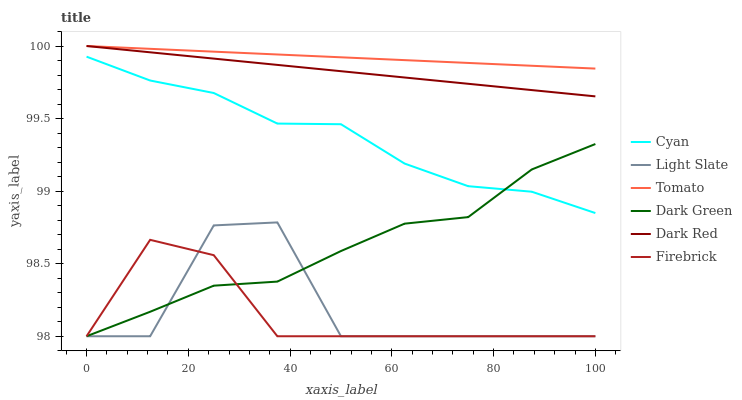Does Firebrick have the minimum area under the curve?
Answer yes or no. Yes. Does Tomato have the maximum area under the curve?
Answer yes or no. Yes. Does Light Slate have the minimum area under the curve?
Answer yes or no. No. Does Light Slate have the maximum area under the curve?
Answer yes or no. No. Is Dark Red the smoothest?
Answer yes or no. Yes. Is Light Slate the roughest?
Answer yes or no. Yes. Is Light Slate the smoothest?
Answer yes or no. No. Is Dark Red the roughest?
Answer yes or no. No. Does Dark Red have the lowest value?
Answer yes or no. No. Does Dark Red have the highest value?
Answer yes or no. Yes. Does Light Slate have the highest value?
Answer yes or no. No. Is Light Slate less than Cyan?
Answer yes or no. Yes. Is Cyan greater than Light Slate?
Answer yes or no. Yes. Does Tomato intersect Dark Red?
Answer yes or no. Yes. Is Tomato less than Dark Red?
Answer yes or no. No. Is Tomato greater than Dark Red?
Answer yes or no. No. Does Light Slate intersect Cyan?
Answer yes or no. No. 